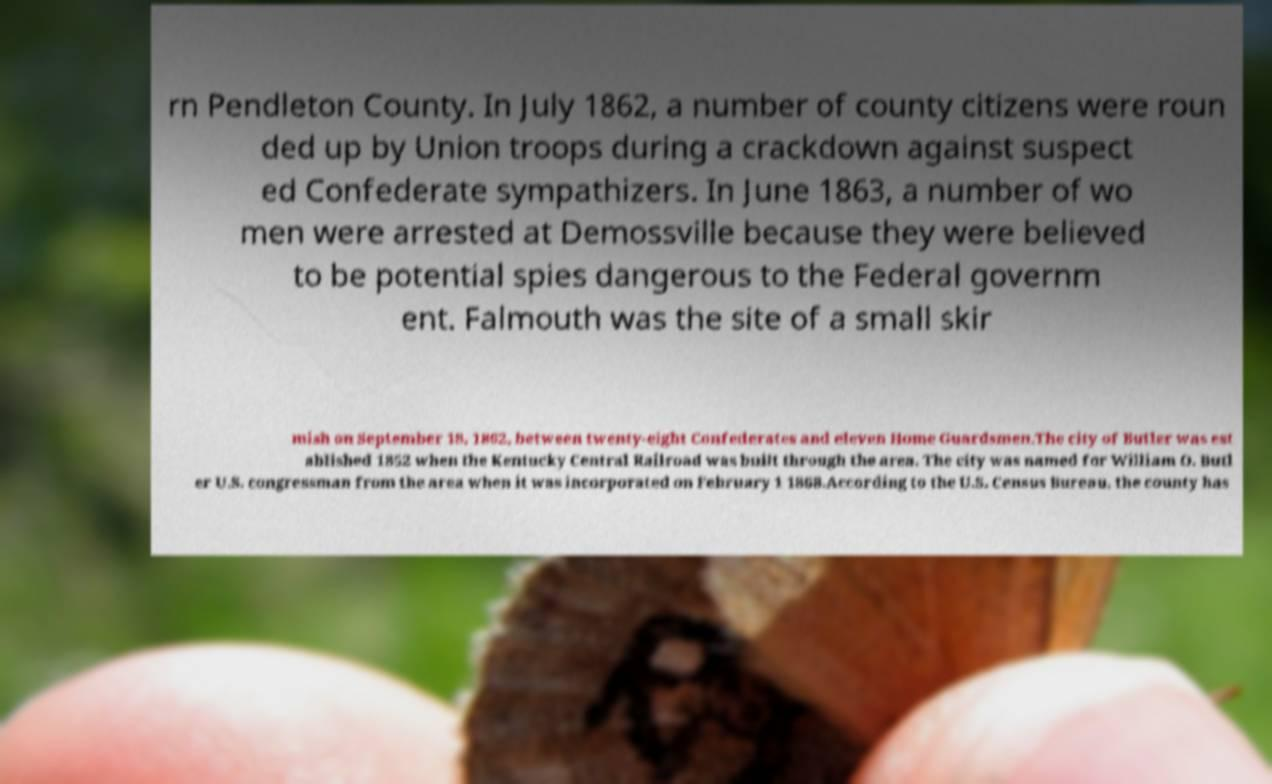There's text embedded in this image that I need extracted. Can you transcribe it verbatim? rn Pendleton County. In July 1862, a number of county citizens were roun ded up by Union troops during a crackdown against suspect ed Confederate sympathizers. In June 1863, a number of wo men were arrested at Demossville because they were believed to be potential spies dangerous to the Federal governm ent. Falmouth was the site of a small skir mish on September 18, 1862, between twenty-eight Confederates and eleven Home Guardsmen.The city of Butler was est ablished 1852 when the Kentucky Central Railroad was built through the area. The city was named for William O. Butl er U.S. congressman from the area when it was incorporated on February 1 1868.According to the U.S. Census Bureau, the county has 